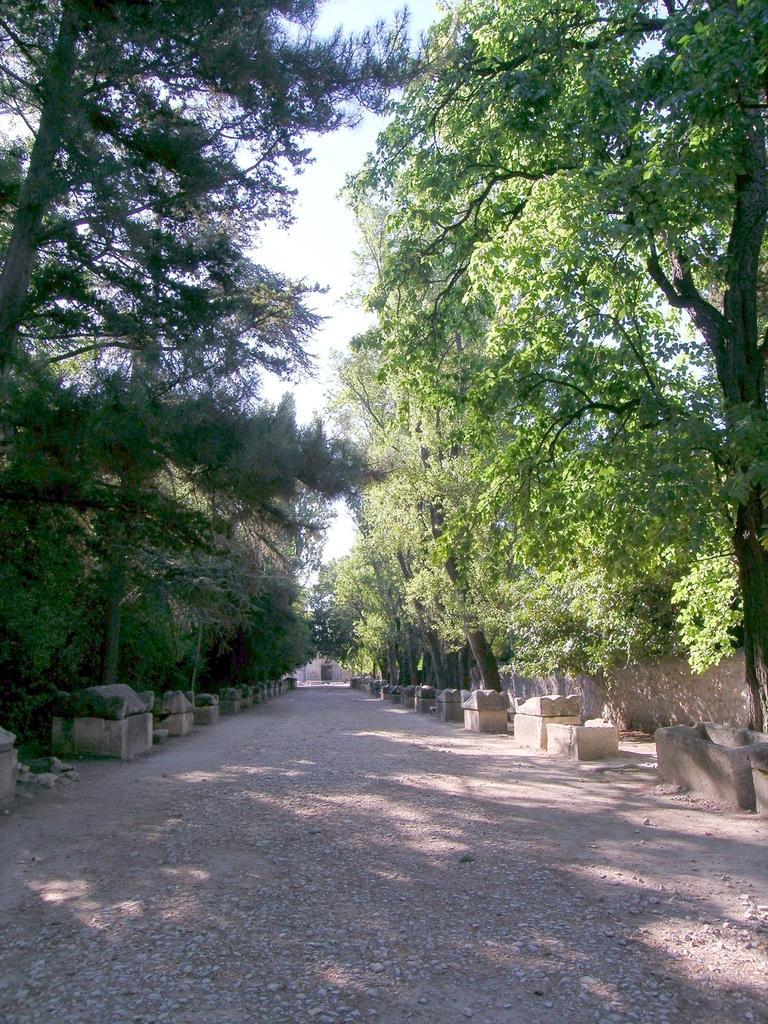In one or two sentences, can you explain what this image depicts? In this image I can see the road and few concrete structures on both sides of the road. I can see few trees on both sides of the road and the wall on the right side of the image. In the background I can see the sky. 